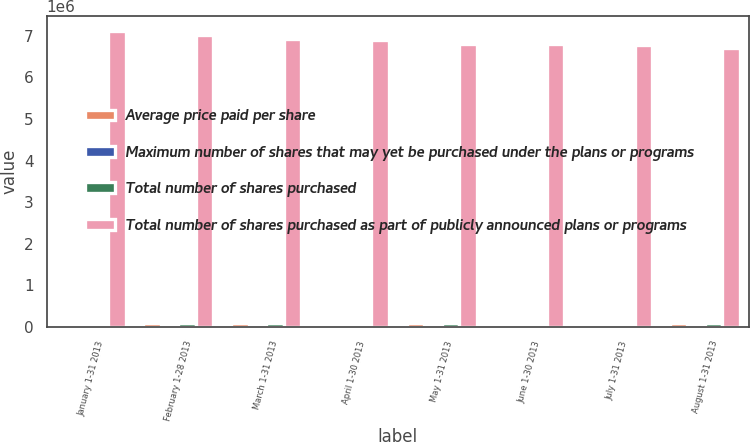Convert chart to OTSL. <chart><loc_0><loc_0><loc_500><loc_500><stacked_bar_chart><ecel><fcel>January 1-31 2013<fcel>February 1-28 2013<fcel>March 1-31 2013<fcel>April 1-30 2013<fcel>May 1-31 2013<fcel>June 1-30 2013<fcel>July 1-31 2013<fcel>August 1-31 2013<nl><fcel>Average price paid per share<fcel>5776<fcel>100628<fcel>93709<fcel>30274<fcel>82600<fcel>7535<fcel>15325<fcel>88935<nl><fcel>Maximum number of shares that may yet be purchased under the plans or programs<fcel>41.73<fcel>44.6<fcel>46.15<fcel>48.17<fcel>49.27<fcel>46.55<fcel>49.06<fcel>49.04<nl><fcel>Total number of shares purchased<fcel>5776<fcel>100628<fcel>93709<fcel>30274<fcel>82600<fcel>7535<fcel>15325<fcel>88935<nl><fcel>Total number of shares purchased as part of publicly announced plans or programs<fcel>7.12146e+06<fcel>7.02083e+06<fcel>6.92712e+06<fcel>6.89685e+06<fcel>6.81425e+06<fcel>6.80672e+06<fcel>6.79139e+06<fcel>6.70246e+06<nl></chart> 